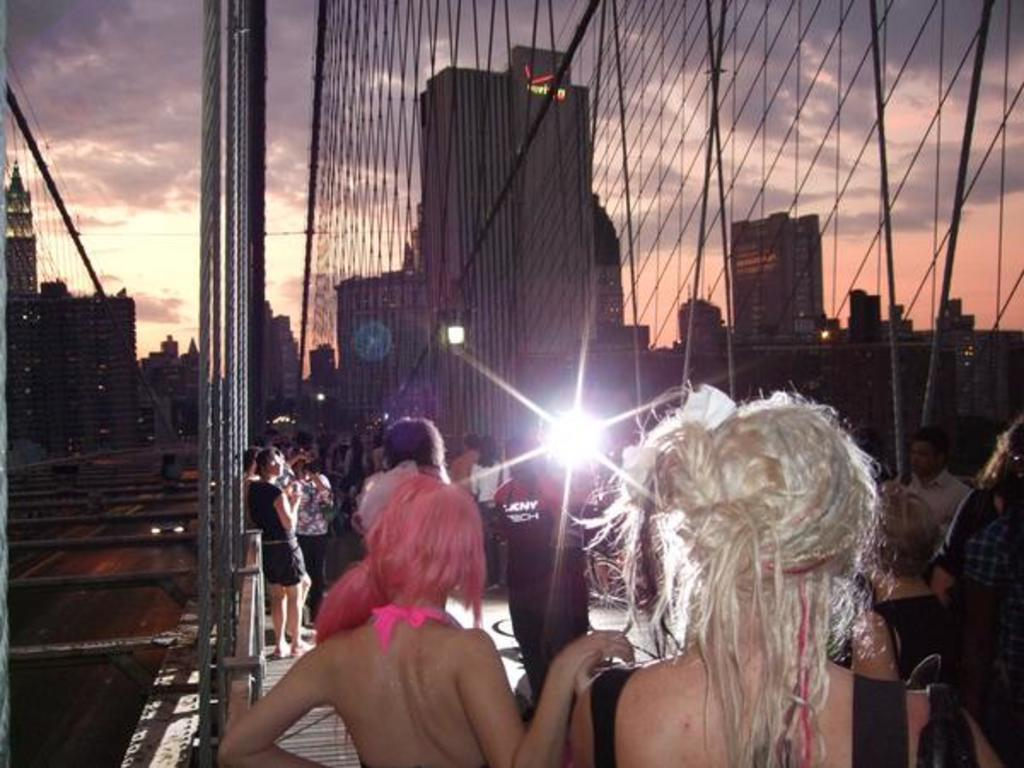What is happening in the image? There are people standing in the image. What structures can be seen in the background? There are buildings in the image. What can be seen illuminating the scene? There are lights visible in the image. What type of natural elements are present in the image? There are clouds in the image. What is visible in the background of the image? The sky is visible in the image. How many lizards can be seen climbing on the buildings in the image? There are no lizards present in the image; it only features people, buildings, lights, clouds, and the sky. 